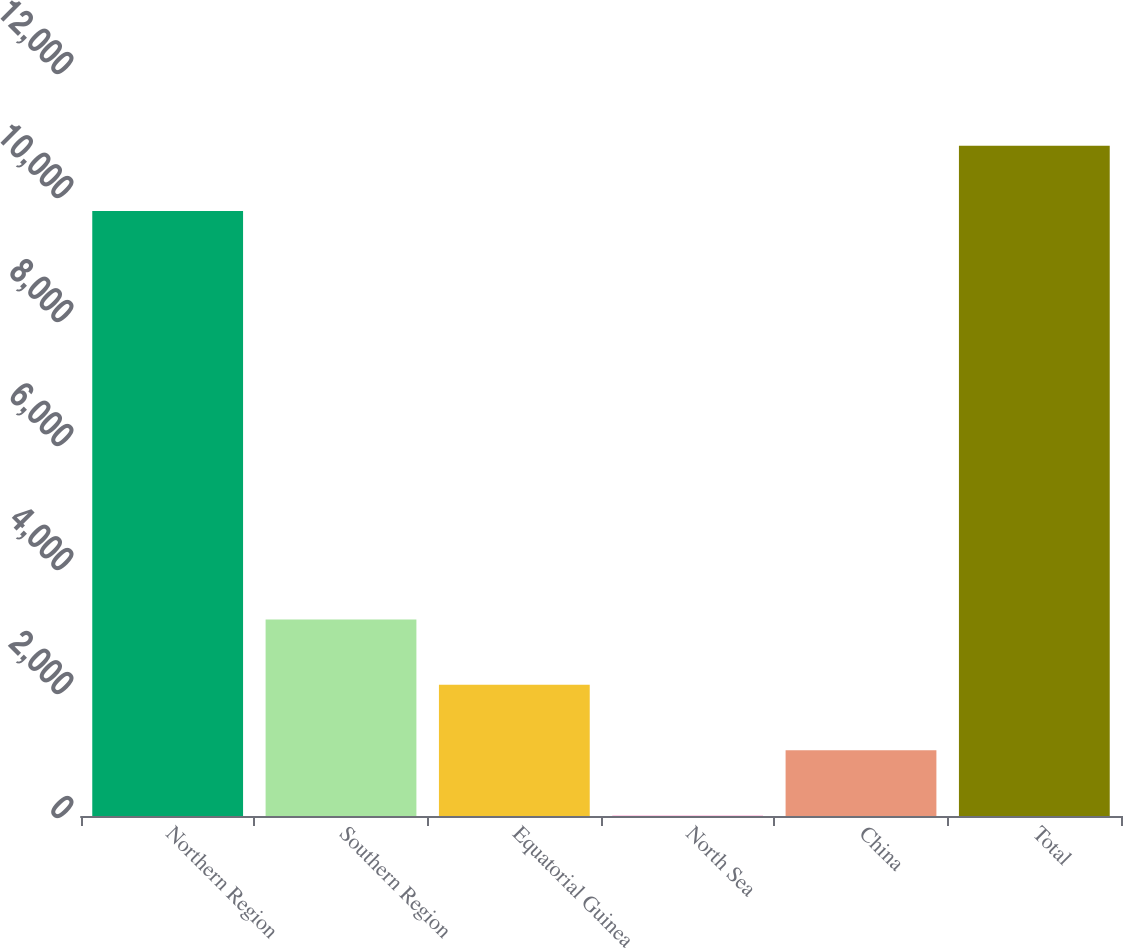Convert chart. <chart><loc_0><loc_0><loc_500><loc_500><bar_chart><fcel>Northern Region<fcel>Southern Region<fcel>Equatorial Guinea<fcel>North Sea<fcel>China<fcel>Total<nl><fcel>9756.9<fcel>3170.37<fcel>2115.48<fcel>5.7<fcel>1060.59<fcel>10811.8<nl></chart> 